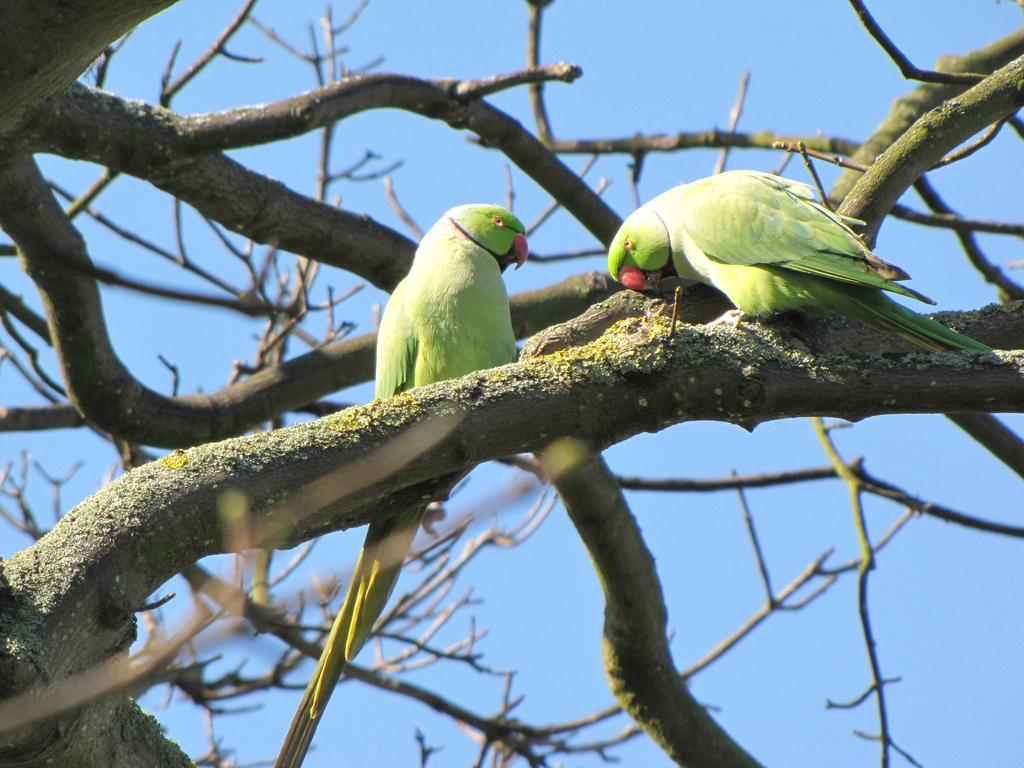What can be seen in the background of the image? The sky is visible in the background of the image. What type of vegetation is present in the image? There are branches in the image. What type of animals can be seen in the image? There are parrots in the image. What type of rings can be seen on the parrots' legs in the image? There are no rings visible on the parrots' legs in the image. What type of prose can be heard being recited by the parrots in the image? There is no prose being recited by the parrots in the image, as parrots do not have the ability to recite prose. 